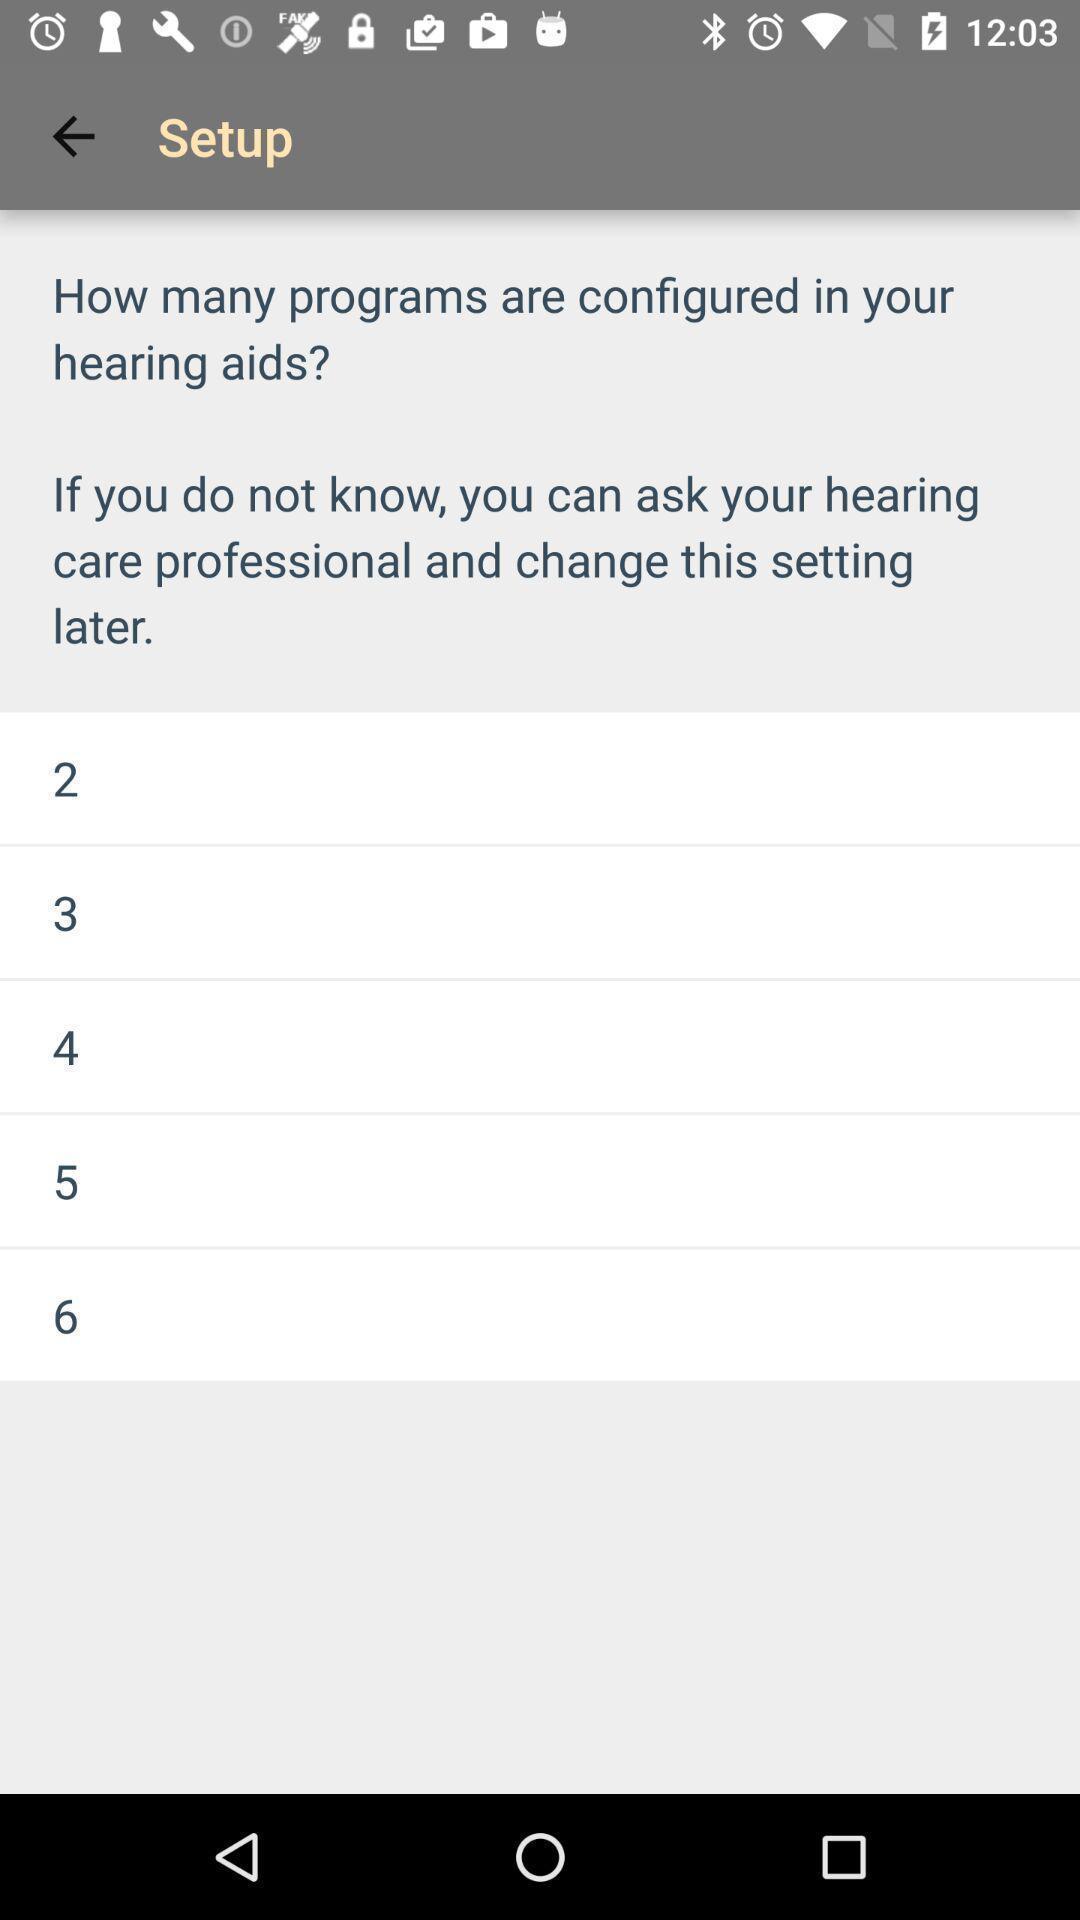Describe the visual elements of this screenshot. Setup page displayed. 